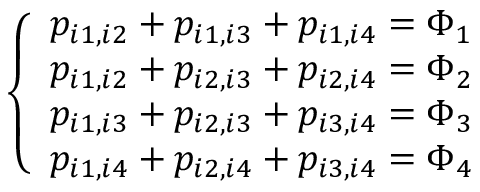<formula> <loc_0><loc_0><loc_500><loc_500>\left \{ \begin{array} { l l } { p _ { i 1 , i 2 } + p _ { i 1 , i 3 } + p _ { i 1 , i 4 } = \Phi _ { 1 } } \\ { p _ { i 1 , i 2 } + p _ { i 2 , i 3 } + p _ { i 2 , i 4 } = \Phi _ { 2 } } \\ { p _ { i 1 , i 3 } + p _ { i 2 , i 3 } + p _ { i 3 , i 4 } = \Phi _ { 3 } } \\ { p _ { i 1 , i 4 } + p _ { i 2 , i 4 } + p _ { i 3 , i 4 } = \Phi _ { 4 } } \end{array}</formula> 